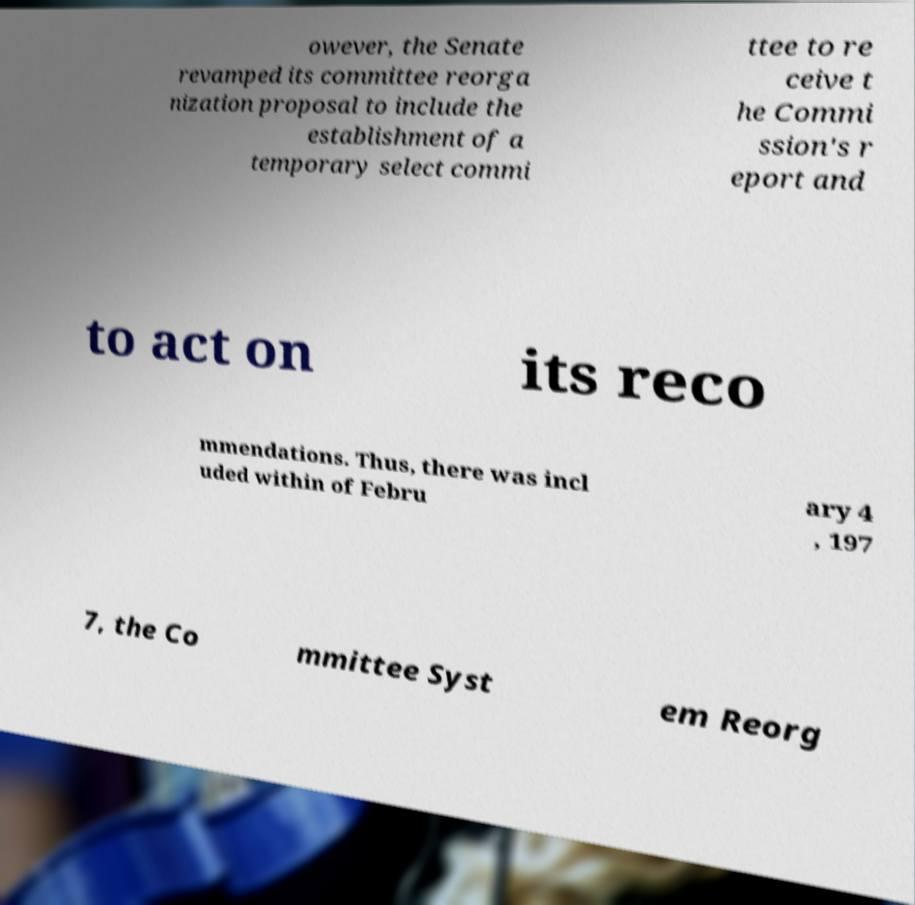Could you assist in decoding the text presented in this image and type it out clearly? owever, the Senate revamped its committee reorga nization proposal to include the establishment of a temporary select commi ttee to re ceive t he Commi ssion's r eport and to act on its reco mmendations. Thus, there was incl uded within of Febru ary 4 , 197 7, the Co mmittee Syst em Reorg 